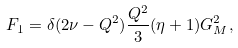<formula> <loc_0><loc_0><loc_500><loc_500>F _ { 1 } = \delta ( 2 \nu - Q ^ { 2 } ) \frac { Q ^ { 2 } } { 3 } ( \eta + 1 ) G _ { M } ^ { 2 } ,</formula> 